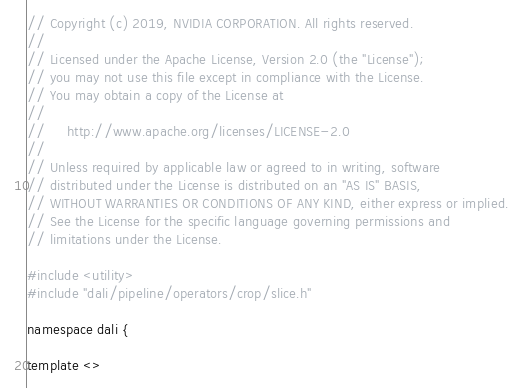<code> <loc_0><loc_0><loc_500><loc_500><_Cuda_>// Copyright (c) 2019, NVIDIA CORPORATION. All rights reserved.
//
// Licensed under the Apache License, Version 2.0 (the "License");
// you may not use this file except in compliance with the License.
// You may obtain a copy of the License at
//
//     http://www.apache.org/licenses/LICENSE-2.0
//
// Unless required by applicable law or agreed to in writing, software
// distributed under the License is distributed on an "AS IS" BASIS,
// WITHOUT WARRANTIES OR CONDITIONS OF ANY KIND, either express or implied.
// See the License for the specific language governing permissions and
// limitations under the License.

#include <utility>
#include "dali/pipeline/operators/crop/slice.h"

namespace dali {

template <></code> 